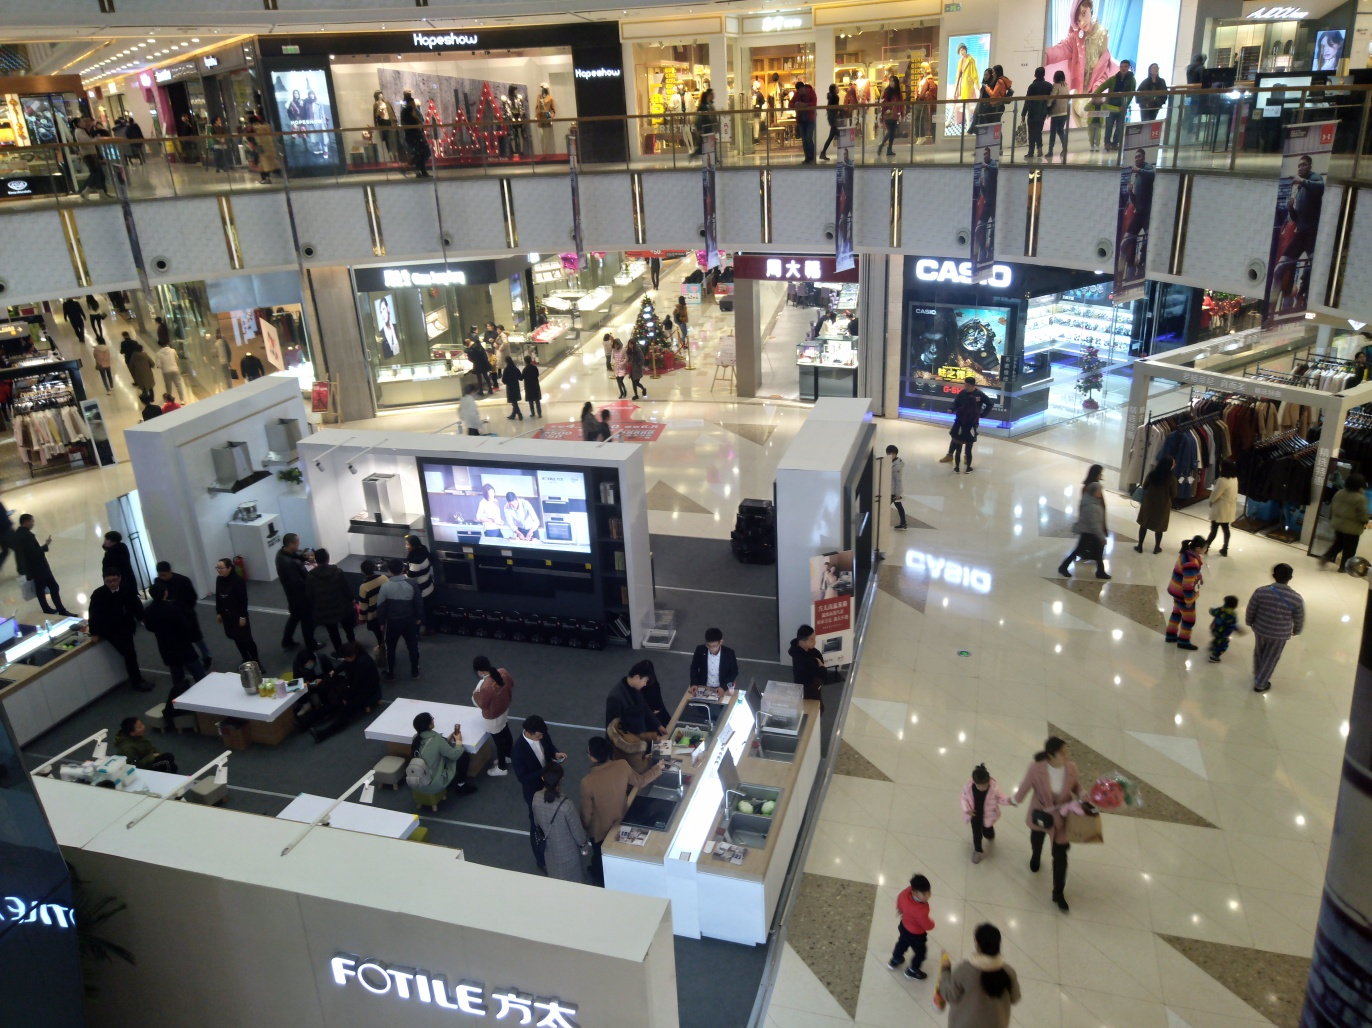Can you tell me about the brands or types of stores visible in this image? Even though specific brand names are not clearly visible, the stores seem to offer a range of products including clothing, accessories, and home appliances. There's a kiosk labeled 'FOTILE' suggesting they sell kitchen appliances, and various fashion-related stores are apparent based on the clothing displayed in the windows. Do the stores cater to a specific demographic? It's difficult to determine the exact demographic from the image alone, but the variety of stores, from home appliances to fashion, suggests that the mall caters to a wide range of customers, including families, young adults, and professionals looking for a diverse shopping experience. 